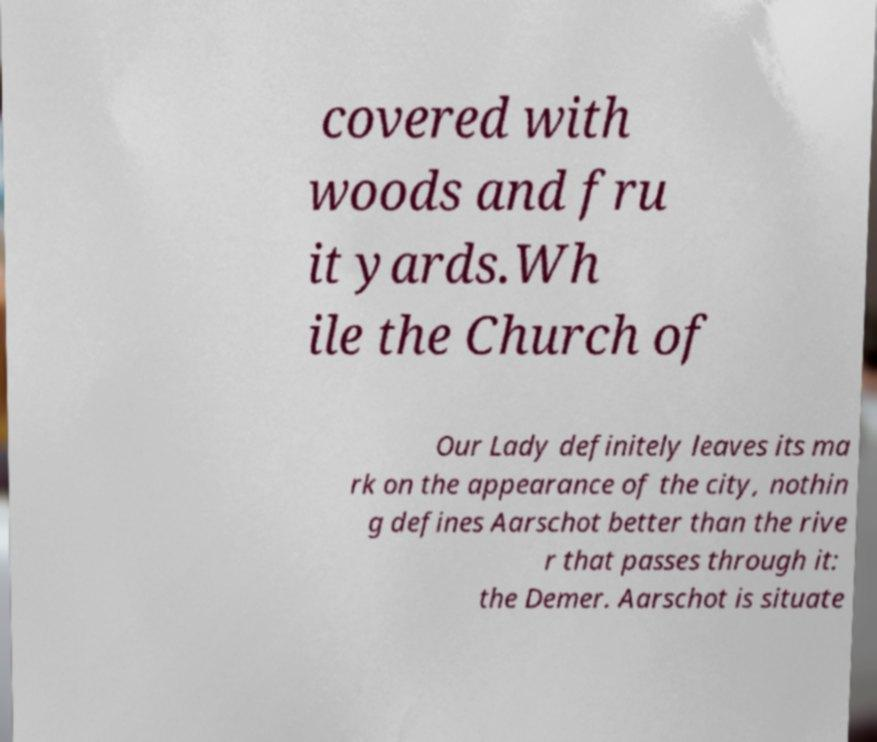Please read and relay the text visible in this image. What does it say? covered with woods and fru it yards.Wh ile the Church of Our Lady definitely leaves its ma rk on the appearance of the city, nothin g defines Aarschot better than the rive r that passes through it: the Demer. Aarschot is situate 